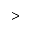Convert formula to latex. <formula><loc_0><loc_0><loc_500><loc_500>></formula> 